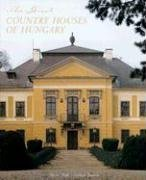What type of book is this? While the book falls under the travel genre, it is more specifically a detailed guide to the opulent and historical country houses of Hungary, likely filled with rich architectural insights and cultural history. 